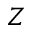Convert formula to latex. <formula><loc_0><loc_0><loc_500><loc_500>Z</formula> 